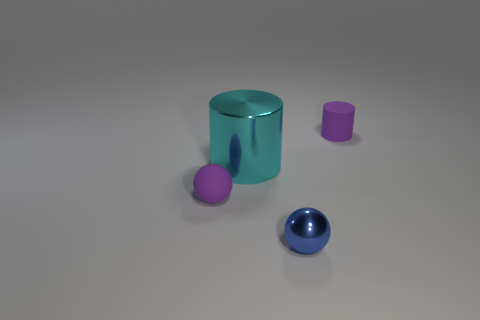Are there any other things that are the same size as the shiny cylinder?
Offer a very short reply. No. Is the material of the purple cylinder the same as the big cyan cylinder?
Offer a very short reply. No. What is the color of the rubber sphere left of the matte thing that is on the right side of the tiny blue thing?
Provide a short and direct response. Purple. There is a cyan object that is made of the same material as the small blue sphere; what is its size?
Your answer should be very brief. Large. What number of other large cyan matte objects are the same shape as the cyan thing?
Make the answer very short. 0. What number of things are tiny rubber things behind the cyan shiny thing or small matte spheres that are to the left of the small metallic sphere?
Ensure brevity in your answer.  2. There is a ball that is in front of the small purple ball; how many cyan things are on the right side of it?
Make the answer very short. 0. There is a thing behind the large cylinder; does it have the same shape as the matte object left of the big cyan thing?
Your answer should be compact. No. What shape is the matte object that is the same color as the tiny matte cylinder?
Your answer should be compact. Sphere. Is there a purple thing made of the same material as the tiny purple cylinder?
Offer a terse response. Yes. 